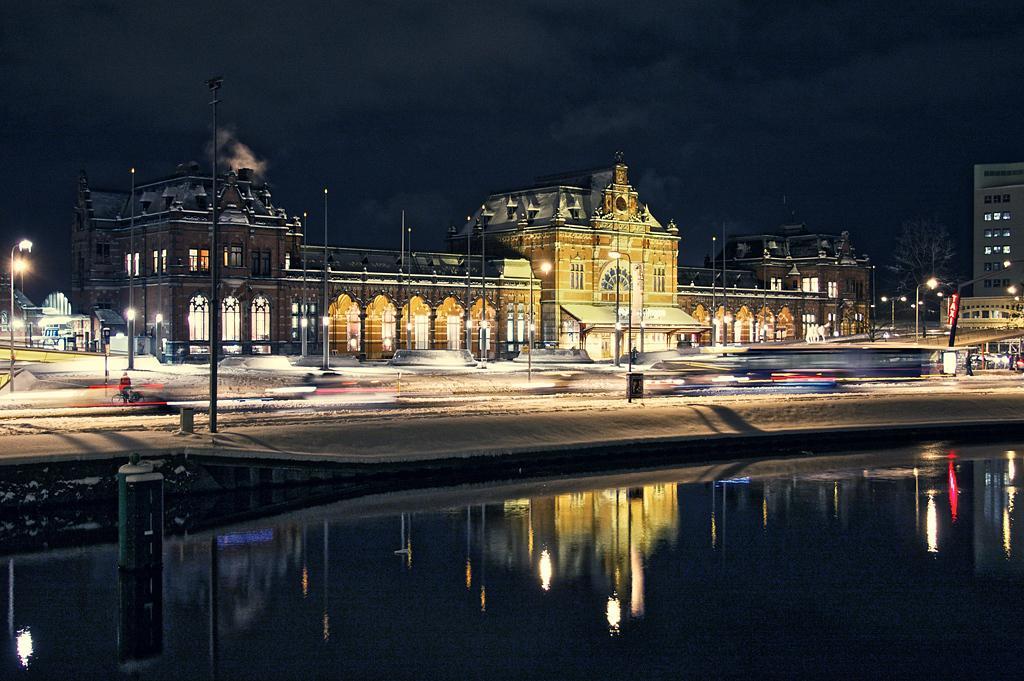Describe this image in one or two sentences. In this image we can see poles, lights, buildings, tree, and water. On the water we can see the reflection. In the background there is sky. 